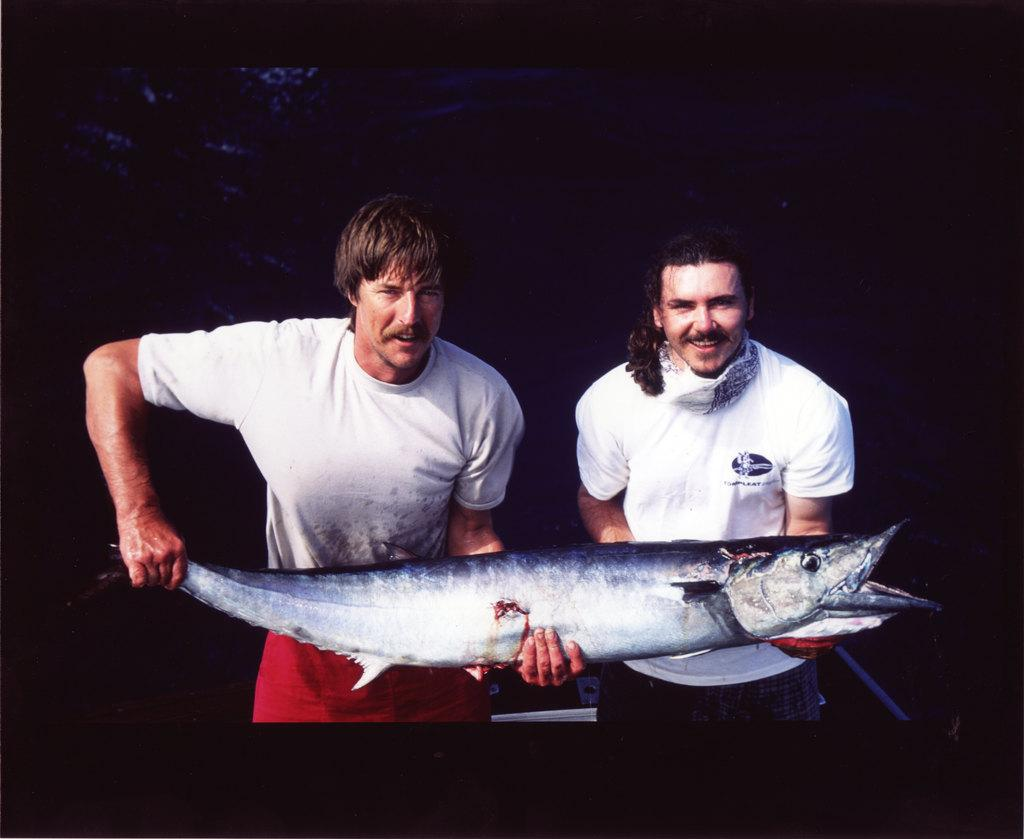How many people are in the image? There are two people in the image. What are the two people holding? The two people are holding fish. What can be observed about the background of the image? The background of the image is dark. What type of drug can be seen in the image? There is no drug present in the image. What sound can be heard coming from the fish in the image? There is no sound coming from the fish in the image, as fish do not produce audible sounds. 